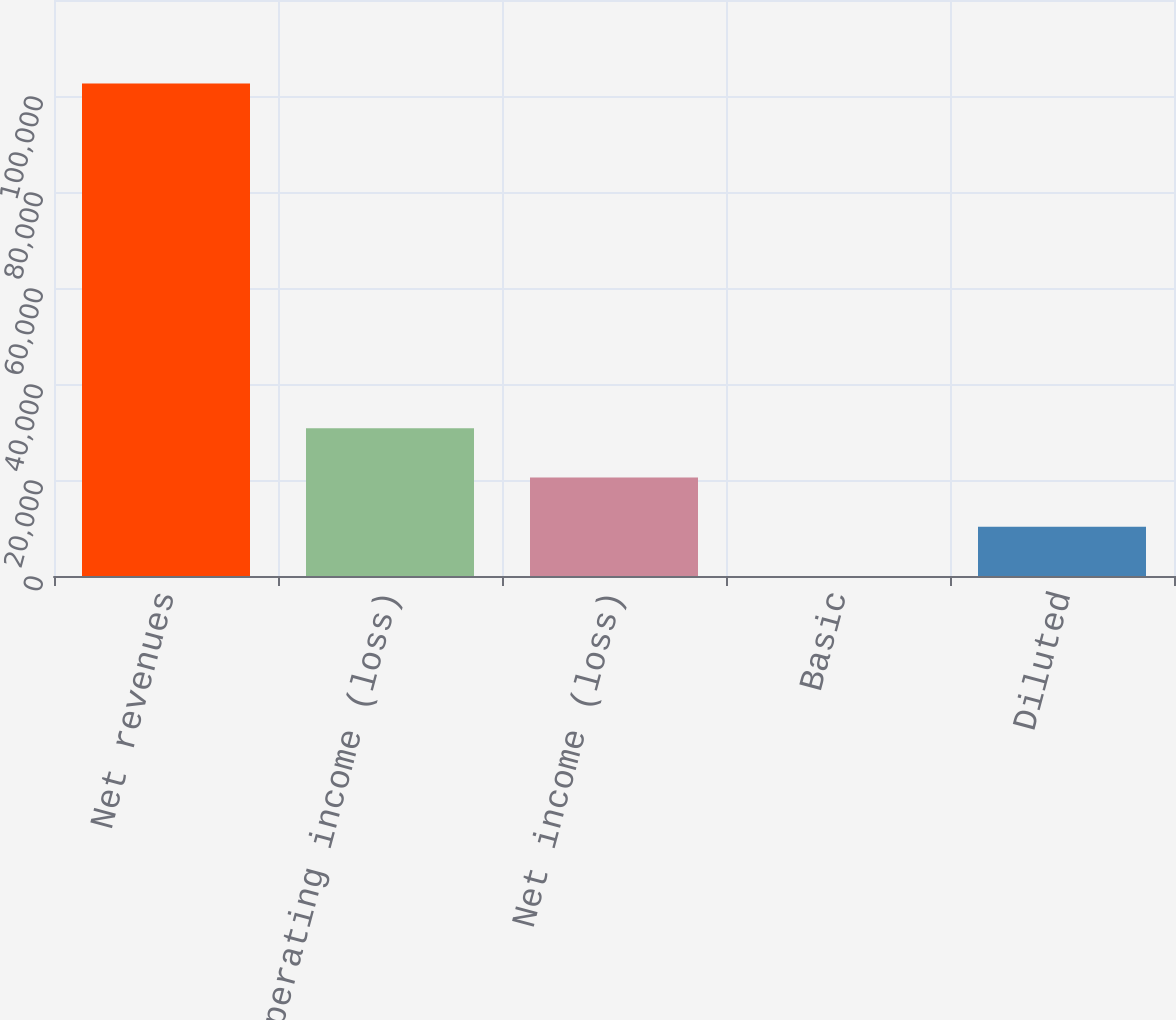Convert chart to OTSL. <chart><loc_0><loc_0><loc_500><loc_500><bar_chart><fcel>Net revenues<fcel>Operating income (loss)<fcel>Net income (loss)<fcel>Basic<fcel>Diluted<nl><fcel>102606<fcel>30781.8<fcel>20521.2<fcel>0.05<fcel>10260.6<nl></chart> 